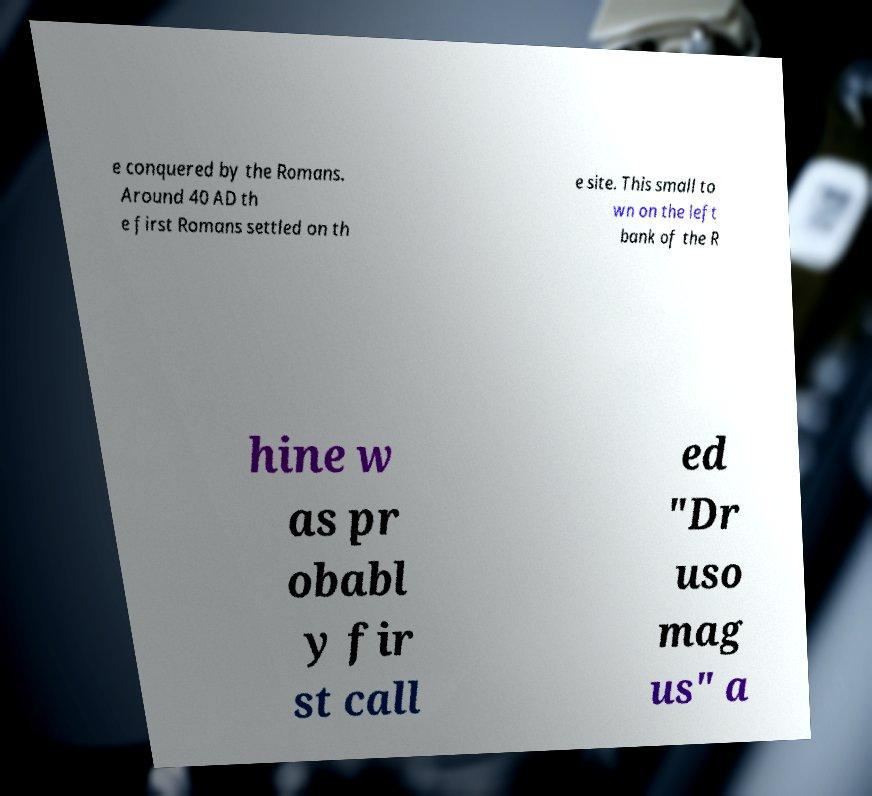What messages or text are displayed in this image? I need them in a readable, typed format. e conquered by the Romans. Around 40 AD th e first Romans settled on th e site. This small to wn on the left bank of the R hine w as pr obabl y fir st call ed "Dr uso mag us" a 